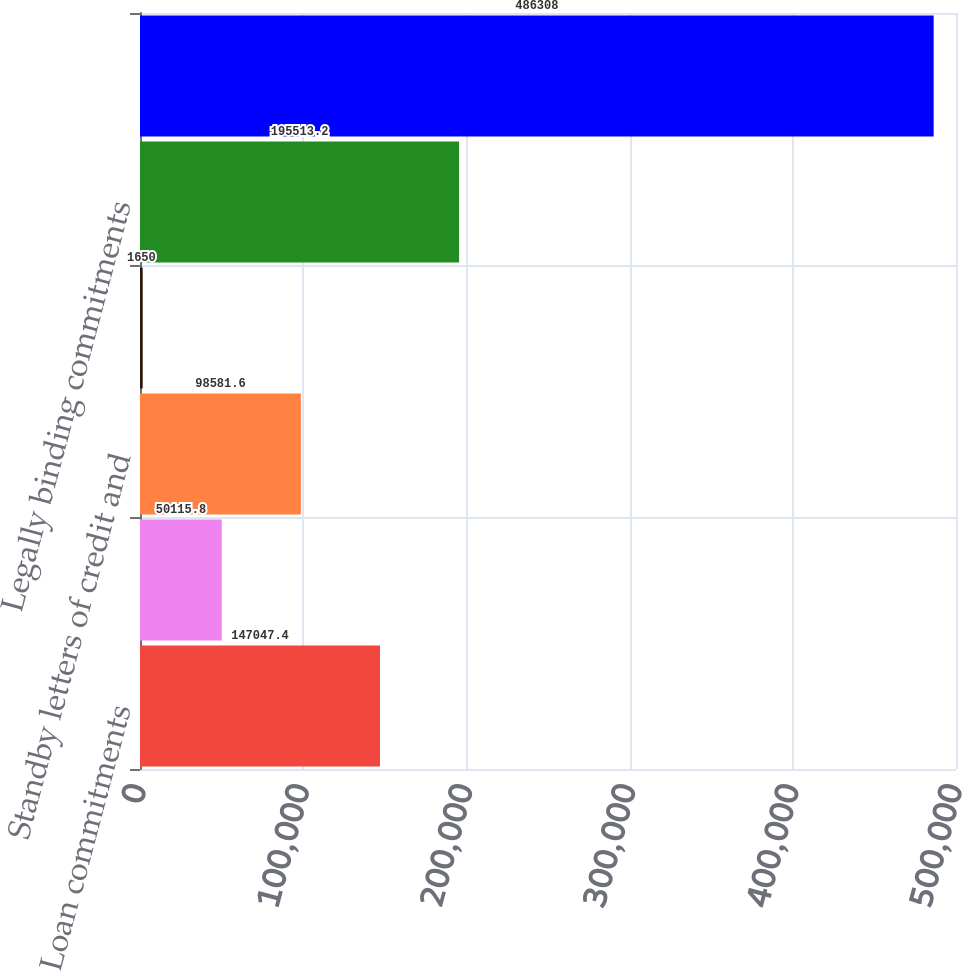Convert chart to OTSL. <chart><loc_0><loc_0><loc_500><loc_500><bar_chart><fcel>Loan commitments<fcel>Home equity lines of credit<fcel>Standby letters of credit and<fcel>Letters of credit<fcel>Legally binding commitments<fcel>Total credit extension<nl><fcel>147047<fcel>50115.8<fcel>98581.6<fcel>1650<fcel>195513<fcel>486308<nl></chart> 